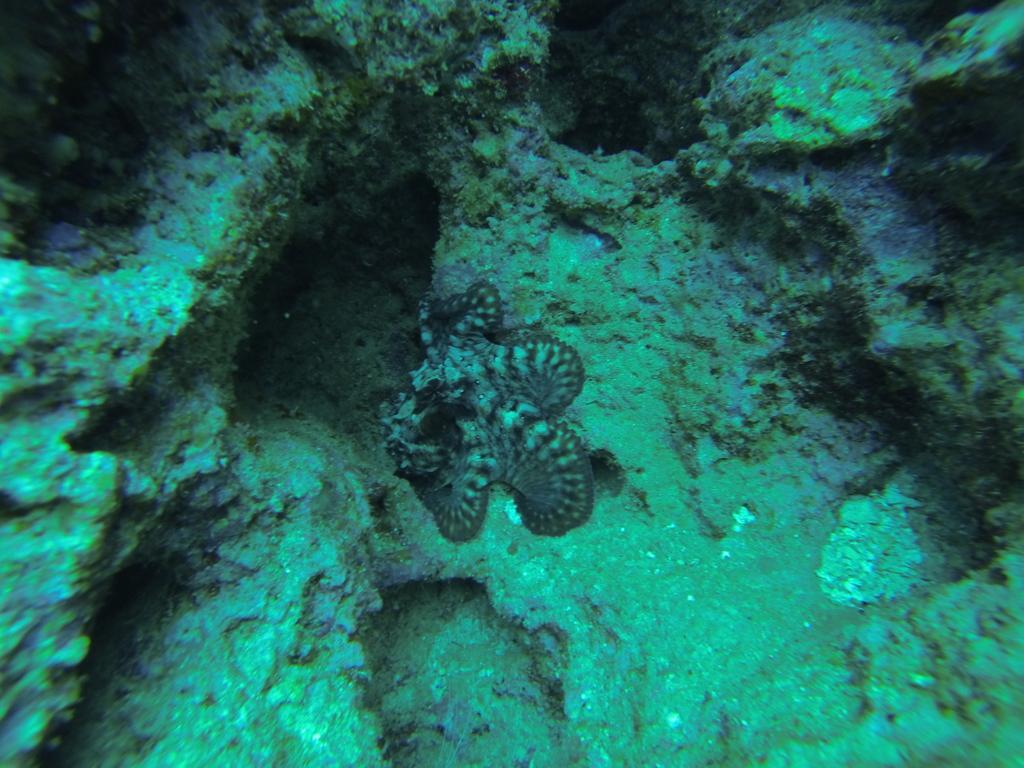What is the setting of the image? The image is taken underwater. What marine creature can be seen in the image? There is a starfish in the image. What type of objects are present at the bottom of the image? There are stones at the bottom of the image. What type of punishment is being administered to the sheep in the image? There is no sheep present in the image, and therefore no punishment is being administered. How many snakes can be seen slithering in the image? There are no snakes present in the image. 